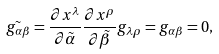<formula> <loc_0><loc_0><loc_500><loc_500>\tilde { g _ { \alpha \beta } } = \frac { \partial x ^ { \lambda } } { \partial \tilde { \alpha } } \frac { \partial x ^ { \rho } } { \partial \tilde { \beta } } g _ { \lambda \rho } = g _ { \alpha \beta } = 0 ,</formula> 